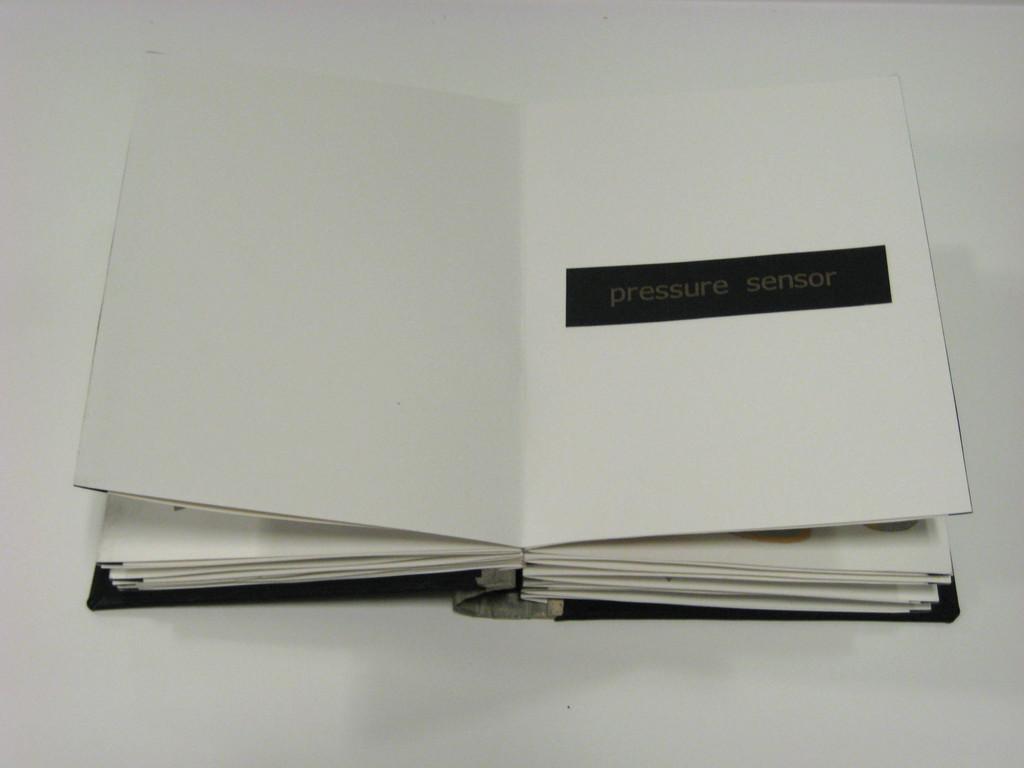What type of sensor is labeled here?
Provide a succinct answer. Pressure sensor. Is pressure sensor the name of this type of book?
Offer a terse response. Yes. 